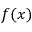Convert formula to latex. <formula><loc_0><loc_0><loc_500><loc_500>f ( x )</formula> 